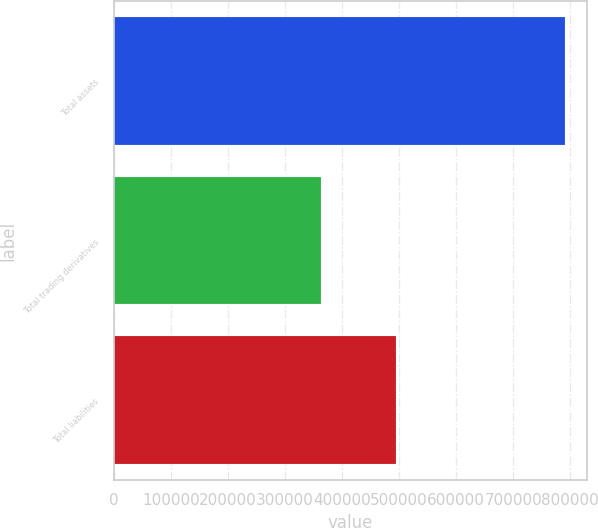Convert chart. <chart><loc_0><loc_0><loc_500><loc_500><bar_chart><fcel>Total assets<fcel>Total trading derivatives<fcel>Total liabilities<nl><fcel>790217<fcel>363466<fcel>494879<nl></chart> 